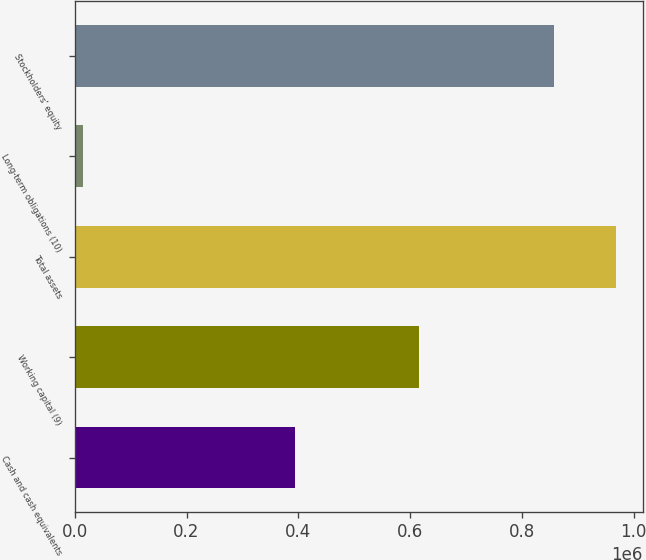Convert chart. <chart><loc_0><loc_0><loc_500><loc_500><bar_chart><fcel>Cash and cash equivalents<fcel>Working capital (9)<fcel>Total assets<fcel>Long-term obligations (10)<fcel>Stockholders' equity<nl><fcel>394075<fcel>615649<fcel>967748<fcel>14229<fcel>857002<nl></chart> 